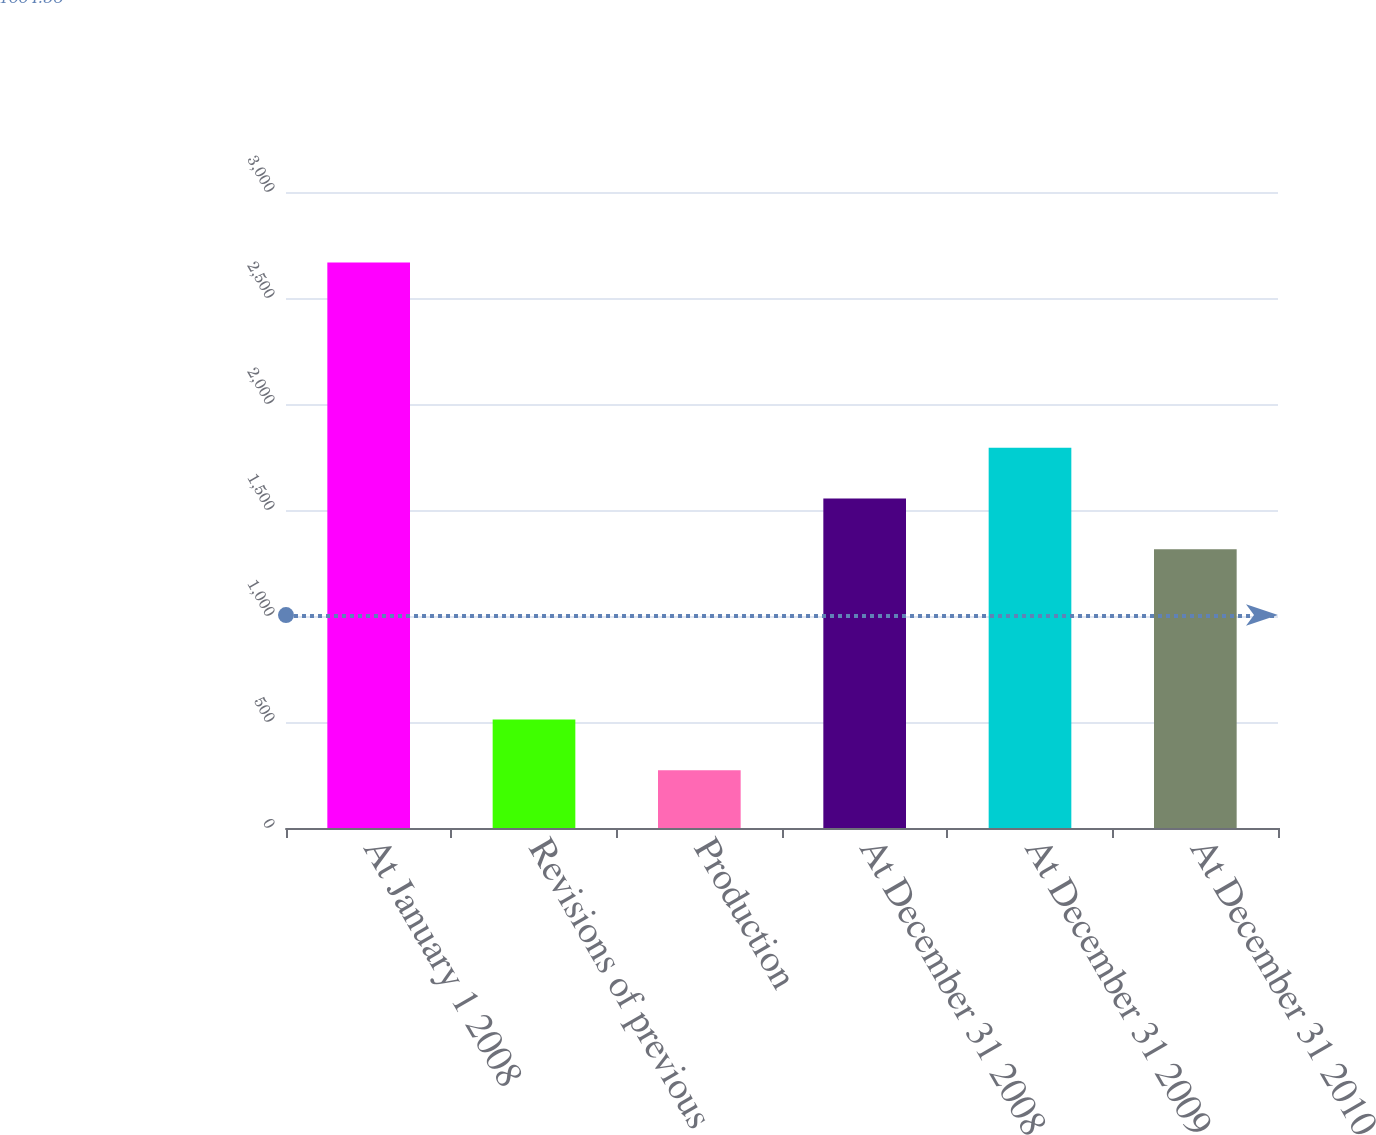Convert chart to OTSL. <chart><loc_0><loc_0><loc_500><loc_500><bar_chart><fcel>At January 1 2008<fcel>Revisions of previous<fcel>Production<fcel>At December 31 2008<fcel>At December 31 2009<fcel>At December 31 2010<nl><fcel>2668<fcel>511.6<fcel>272<fcel>1554.6<fcel>1794.2<fcel>1315<nl></chart> 